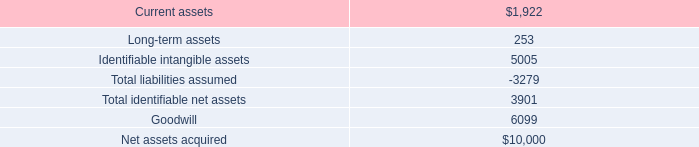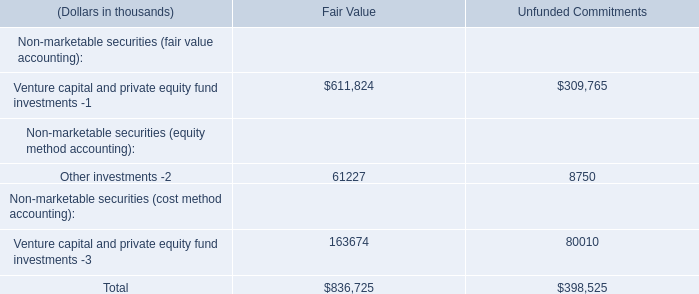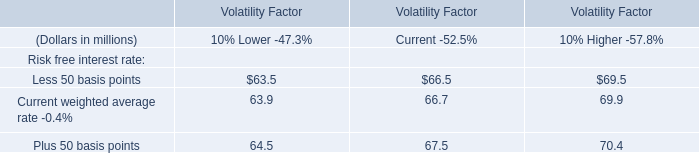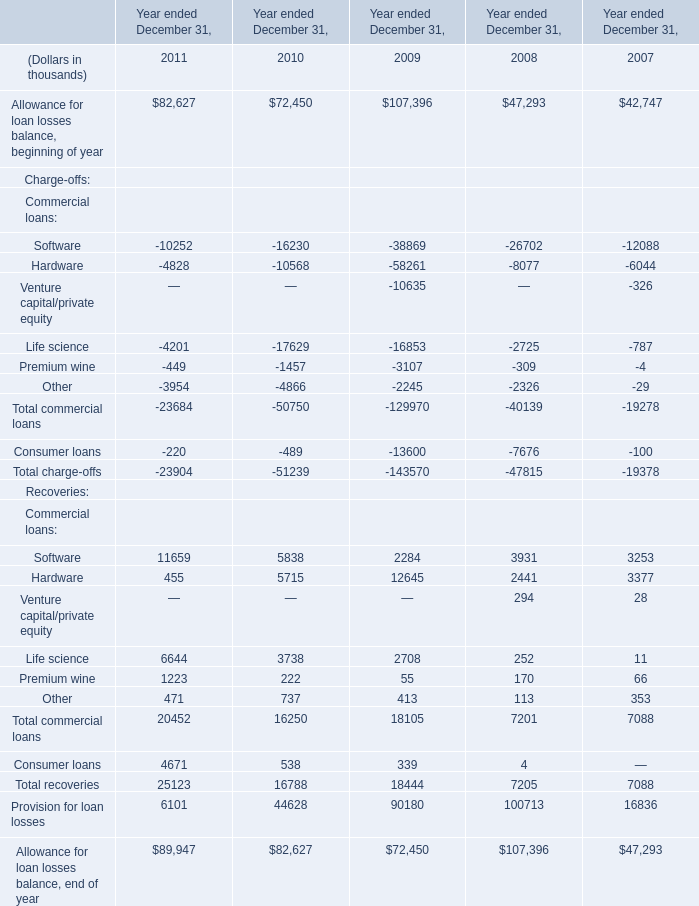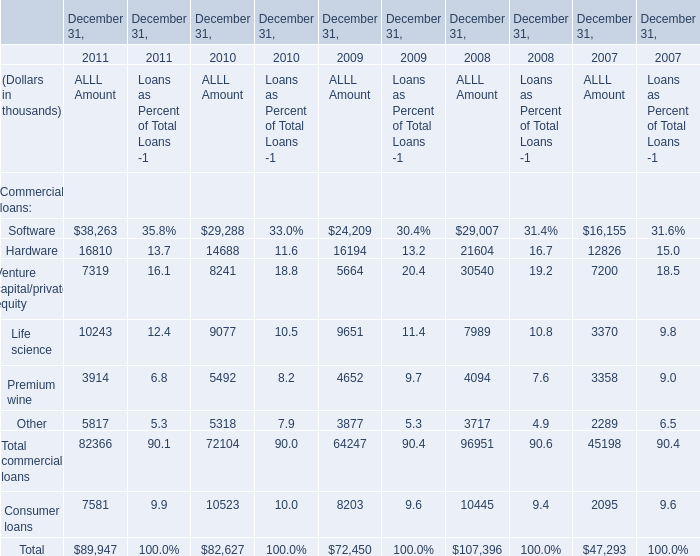What will Hardware for ALLL Amount reach in 2012 if it continues to grow at its current rate? (in thousand) 
Computations: (16810 * (1 + ((16810 - 14688) / 14688)))
Answer: 19238.5689. 